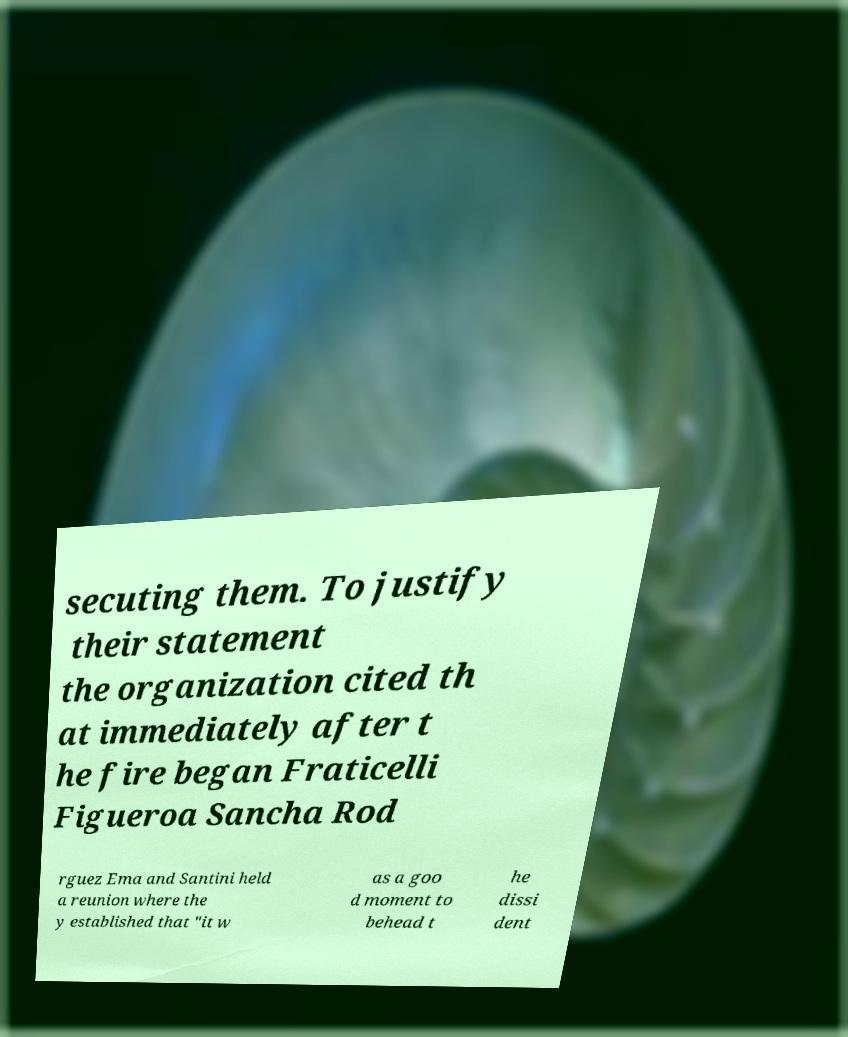Can you accurately transcribe the text from the provided image for me? secuting them. To justify their statement the organization cited th at immediately after t he fire began Fraticelli Figueroa Sancha Rod rguez Ema and Santini held a reunion where the y established that "it w as a goo d moment to behead t he dissi dent 